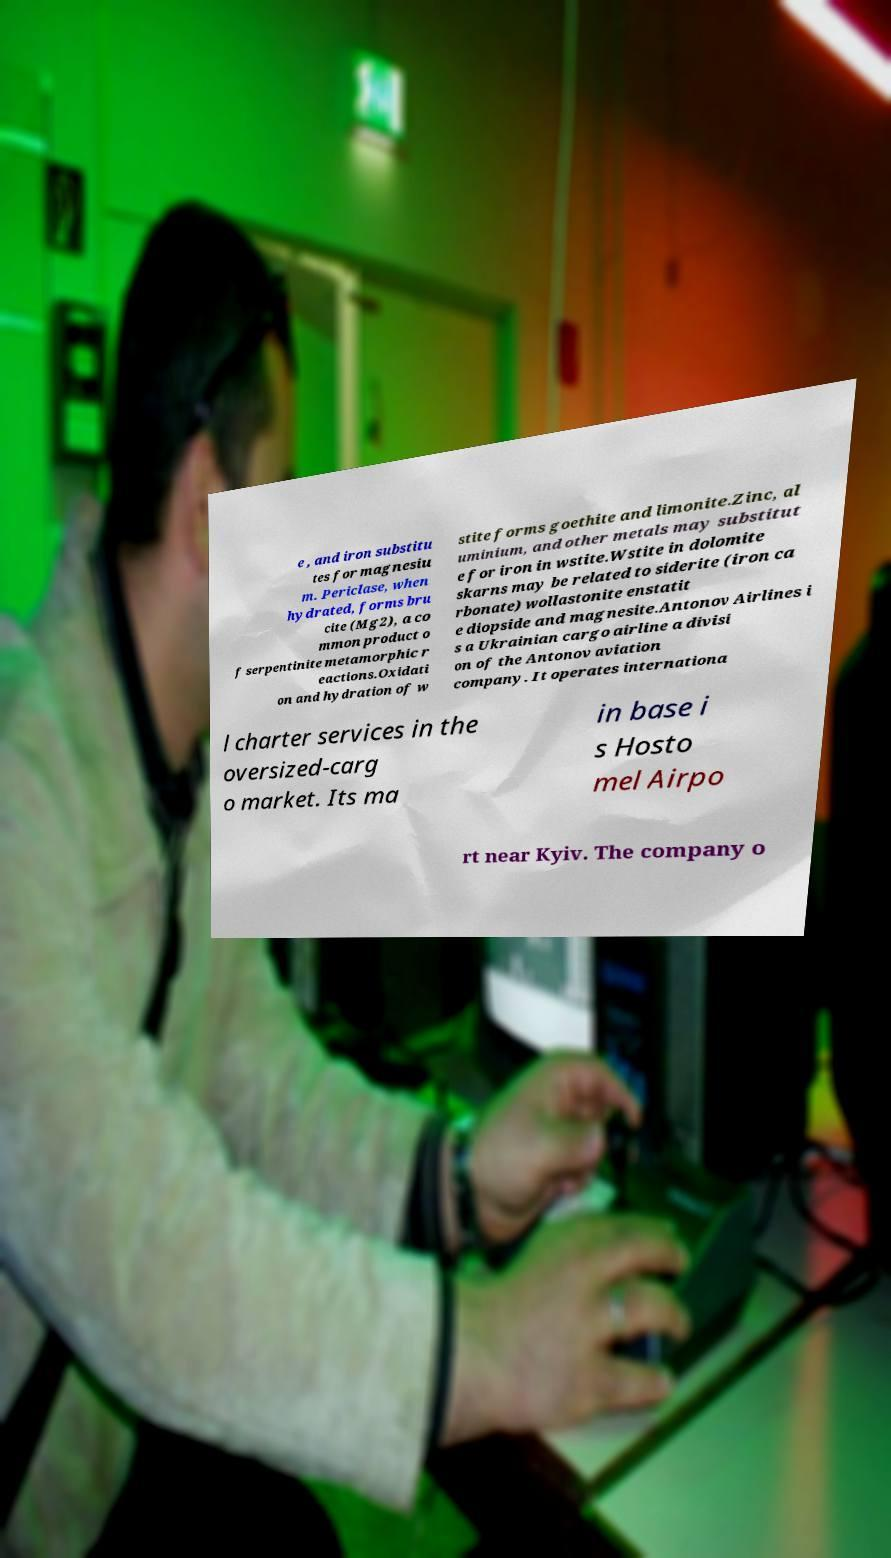What messages or text are displayed in this image? I need them in a readable, typed format. e , and iron substitu tes for magnesiu m. Periclase, when hydrated, forms bru cite (Mg2), a co mmon product o f serpentinite metamorphic r eactions.Oxidati on and hydration of w stite forms goethite and limonite.Zinc, al uminium, and other metals may substitut e for iron in wstite.Wstite in dolomite skarns may be related to siderite (iron ca rbonate) wollastonite enstatit e diopside and magnesite.Antonov Airlines i s a Ukrainian cargo airline a divisi on of the Antonov aviation company. It operates internationa l charter services in the oversized-carg o market. Its ma in base i s Hosto mel Airpo rt near Kyiv. The company o 